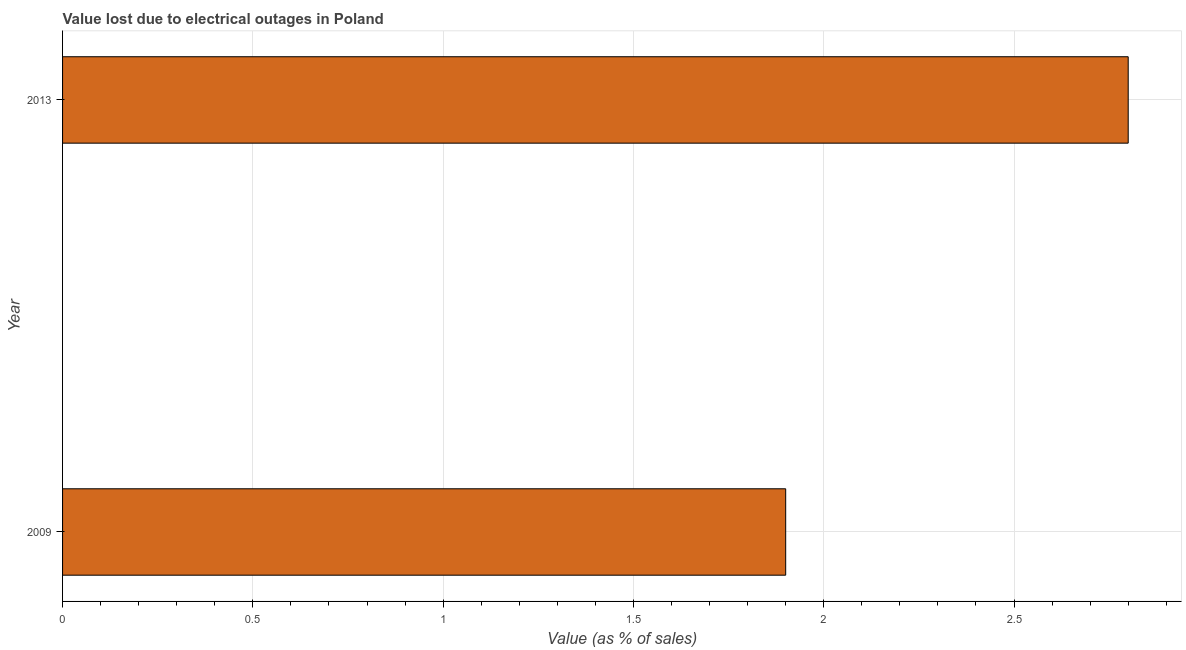What is the title of the graph?
Provide a short and direct response. Value lost due to electrical outages in Poland. What is the label or title of the X-axis?
Your response must be concise. Value (as % of sales). Across all years, what is the minimum value lost due to electrical outages?
Make the answer very short. 1.9. In which year was the value lost due to electrical outages maximum?
Provide a succinct answer. 2013. In which year was the value lost due to electrical outages minimum?
Offer a very short reply. 2009. What is the sum of the value lost due to electrical outages?
Ensure brevity in your answer.  4.7. What is the average value lost due to electrical outages per year?
Provide a short and direct response. 2.35. What is the median value lost due to electrical outages?
Your answer should be very brief. 2.35. Do a majority of the years between 2009 and 2013 (inclusive) have value lost due to electrical outages greater than 0.2 %?
Your answer should be very brief. Yes. What is the ratio of the value lost due to electrical outages in 2009 to that in 2013?
Make the answer very short. 0.68. Is the value lost due to electrical outages in 2009 less than that in 2013?
Offer a terse response. Yes. In how many years, is the value lost due to electrical outages greater than the average value lost due to electrical outages taken over all years?
Your answer should be very brief. 1. What is the difference between two consecutive major ticks on the X-axis?
Offer a very short reply. 0.5. What is the Value (as % of sales) in 2013?
Make the answer very short. 2.8. What is the ratio of the Value (as % of sales) in 2009 to that in 2013?
Make the answer very short. 0.68. 